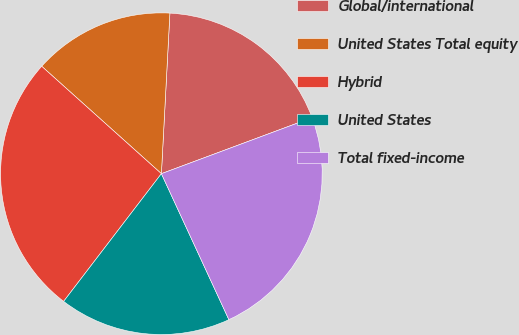Convert chart. <chart><loc_0><loc_0><loc_500><loc_500><pie_chart><fcel>Global/international<fcel>United States Total equity<fcel>Hybrid<fcel>United States<fcel>Total fixed-income<nl><fcel>18.49%<fcel>14.2%<fcel>26.24%<fcel>17.29%<fcel>23.77%<nl></chart> 